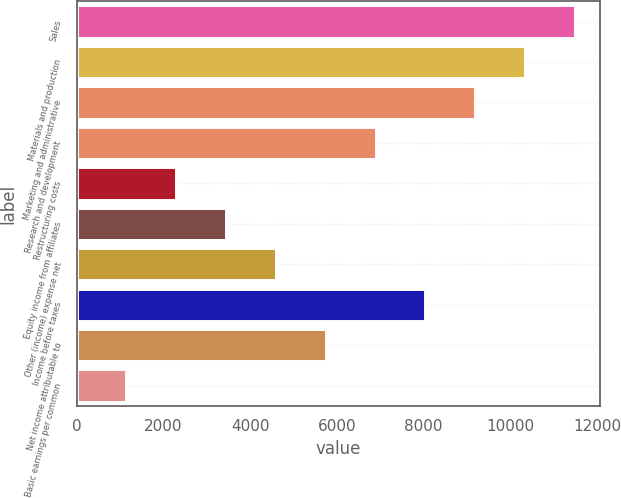Convert chart. <chart><loc_0><loc_0><loc_500><loc_500><bar_chart><fcel>Sales<fcel>Materials and production<fcel>Marketing and administrative<fcel>Research and development<fcel>Restructuring costs<fcel>Equity income from affiliates<fcel>Other (income) expense net<fcel>Income before taxes<fcel>Net income attributable to<fcel>Basic earnings per common<nl><fcel>11488<fcel>10339.2<fcel>9190.48<fcel>6893<fcel>2298.04<fcel>3446.78<fcel>4595.52<fcel>8041.74<fcel>5744.26<fcel>1149.3<nl></chart> 